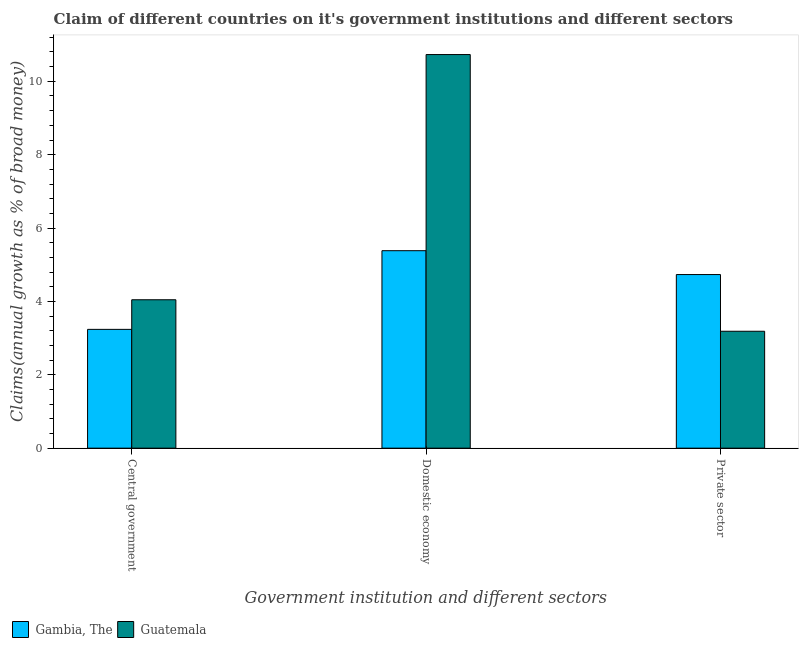Are the number of bars per tick equal to the number of legend labels?
Provide a short and direct response. Yes. How many bars are there on the 1st tick from the left?
Keep it short and to the point. 2. How many bars are there on the 3rd tick from the right?
Make the answer very short. 2. What is the label of the 3rd group of bars from the left?
Keep it short and to the point. Private sector. What is the percentage of claim on the domestic economy in Guatemala?
Ensure brevity in your answer.  10.73. Across all countries, what is the maximum percentage of claim on the domestic economy?
Your answer should be very brief. 10.73. Across all countries, what is the minimum percentage of claim on the central government?
Ensure brevity in your answer.  3.24. In which country was the percentage of claim on the private sector maximum?
Your answer should be very brief. Gambia, The. In which country was the percentage of claim on the private sector minimum?
Provide a succinct answer. Guatemala. What is the total percentage of claim on the central government in the graph?
Your answer should be compact. 7.28. What is the difference between the percentage of claim on the central government in Guatemala and that in Gambia, The?
Give a very brief answer. 0.81. What is the difference between the percentage of claim on the private sector in Gambia, The and the percentage of claim on the central government in Guatemala?
Your answer should be compact. 0.69. What is the average percentage of claim on the domestic economy per country?
Ensure brevity in your answer.  8.06. What is the difference between the percentage of claim on the domestic economy and percentage of claim on the central government in Gambia, The?
Your answer should be very brief. 2.14. What is the ratio of the percentage of claim on the domestic economy in Gambia, The to that in Guatemala?
Provide a succinct answer. 0.5. Is the difference between the percentage of claim on the domestic economy in Gambia, The and Guatemala greater than the difference between the percentage of claim on the central government in Gambia, The and Guatemala?
Provide a succinct answer. No. What is the difference between the highest and the second highest percentage of claim on the private sector?
Give a very brief answer. 1.55. What is the difference between the highest and the lowest percentage of claim on the central government?
Offer a terse response. 0.81. What does the 2nd bar from the left in Domestic economy represents?
Offer a terse response. Guatemala. What does the 2nd bar from the right in Central government represents?
Offer a terse response. Gambia, The. Is it the case that in every country, the sum of the percentage of claim on the central government and percentage of claim on the domestic economy is greater than the percentage of claim on the private sector?
Your answer should be very brief. Yes. How many bars are there?
Ensure brevity in your answer.  6. Are all the bars in the graph horizontal?
Provide a succinct answer. No. Does the graph contain any zero values?
Offer a very short reply. No. How are the legend labels stacked?
Provide a succinct answer. Horizontal. What is the title of the graph?
Offer a terse response. Claim of different countries on it's government institutions and different sectors. What is the label or title of the X-axis?
Offer a very short reply. Government institution and different sectors. What is the label or title of the Y-axis?
Ensure brevity in your answer.  Claims(annual growth as % of broad money). What is the Claims(annual growth as % of broad money) of Gambia, The in Central government?
Your answer should be compact. 3.24. What is the Claims(annual growth as % of broad money) in Guatemala in Central government?
Your response must be concise. 4.05. What is the Claims(annual growth as % of broad money) of Gambia, The in Domestic economy?
Offer a terse response. 5.38. What is the Claims(annual growth as % of broad money) of Guatemala in Domestic economy?
Give a very brief answer. 10.73. What is the Claims(annual growth as % of broad money) of Gambia, The in Private sector?
Ensure brevity in your answer.  4.73. What is the Claims(annual growth as % of broad money) in Guatemala in Private sector?
Offer a very short reply. 3.19. Across all Government institution and different sectors, what is the maximum Claims(annual growth as % of broad money) in Gambia, The?
Make the answer very short. 5.38. Across all Government institution and different sectors, what is the maximum Claims(annual growth as % of broad money) in Guatemala?
Your answer should be compact. 10.73. Across all Government institution and different sectors, what is the minimum Claims(annual growth as % of broad money) in Gambia, The?
Make the answer very short. 3.24. Across all Government institution and different sectors, what is the minimum Claims(annual growth as % of broad money) of Guatemala?
Make the answer very short. 3.19. What is the total Claims(annual growth as % of broad money) in Gambia, The in the graph?
Offer a very short reply. 13.35. What is the total Claims(annual growth as % of broad money) in Guatemala in the graph?
Give a very brief answer. 17.96. What is the difference between the Claims(annual growth as % of broad money) in Gambia, The in Central government and that in Domestic economy?
Offer a very short reply. -2.14. What is the difference between the Claims(annual growth as % of broad money) of Guatemala in Central government and that in Domestic economy?
Your answer should be very brief. -6.68. What is the difference between the Claims(annual growth as % of broad money) of Gambia, The in Central government and that in Private sector?
Your response must be concise. -1.49. What is the difference between the Claims(annual growth as % of broad money) of Guatemala in Central government and that in Private sector?
Keep it short and to the point. 0.86. What is the difference between the Claims(annual growth as % of broad money) of Gambia, The in Domestic economy and that in Private sector?
Your response must be concise. 0.65. What is the difference between the Claims(annual growth as % of broad money) in Guatemala in Domestic economy and that in Private sector?
Offer a very short reply. 7.54. What is the difference between the Claims(annual growth as % of broad money) of Gambia, The in Central government and the Claims(annual growth as % of broad money) of Guatemala in Domestic economy?
Your response must be concise. -7.49. What is the difference between the Claims(annual growth as % of broad money) in Gambia, The in Central government and the Claims(annual growth as % of broad money) in Guatemala in Private sector?
Offer a terse response. 0.05. What is the difference between the Claims(annual growth as % of broad money) in Gambia, The in Domestic economy and the Claims(annual growth as % of broad money) in Guatemala in Private sector?
Provide a short and direct response. 2.2. What is the average Claims(annual growth as % of broad money) in Gambia, The per Government institution and different sectors?
Your answer should be compact. 4.45. What is the average Claims(annual growth as % of broad money) of Guatemala per Government institution and different sectors?
Ensure brevity in your answer.  5.99. What is the difference between the Claims(annual growth as % of broad money) in Gambia, The and Claims(annual growth as % of broad money) in Guatemala in Central government?
Offer a terse response. -0.81. What is the difference between the Claims(annual growth as % of broad money) of Gambia, The and Claims(annual growth as % of broad money) of Guatemala in Domestic economy?
Make the answer very short. -5.35. What is the difference between the Claims(annual growth as % of broad money) of Gambia, The and Claims(annual growth as % of broad money) of Guatemala in Private sector?
Provide a succinct answer. 1.55. What is the ratio of the Claims(annual growth as % of broad money) of Gambia, The in Central government to that in Domestic economy?
Ensure brevity in your answer.  0.6. What is the ratio of the Claims(annual growth as % of broad money) of Guatemala in Central government to that in Domestic economy?
Offer a very short reply. 0.38. What is the ratio of the Claims(annual growth as % of broad money) in Gambia, The in Central government to that in Private sector?
Provide a succinct answer. 0.68. What is the ratio of the Claims(annual growth as % of broad money) of Guatemala in Central government to that in Private sector?
Your response must be concise. 1.27. What is the ratio of the Claims(annual growth as % of broad money) in Gambia, The in Domestic economy to that in Private sector?
Keep it short and to the point. 1.14. What is the ratio of the Claims(annual growth as % of broad money) in Guatemala in Domestic economy to that in Private sector?
Your response must be concise. 3.37. What is the difference between the highest and the second highest Claims(annual growth as % of broad money) in Gambia, The?
Your answer should be compact. 0.65. What is the difference between the highest and the second highest Claims(annual growth as % of broad money) in Guatemala?
Your answer should be compact. 6.68. What is the difference between the highest and the lowest Claims(annual growth as % of broad money) in Gambia, The?
Ensure brevity in your answer.  2.14. What is the difference between the highest and the lowest Claims(annual growth as % of broad money) in Guatemala?
Offer a very short reply. 7.54. 